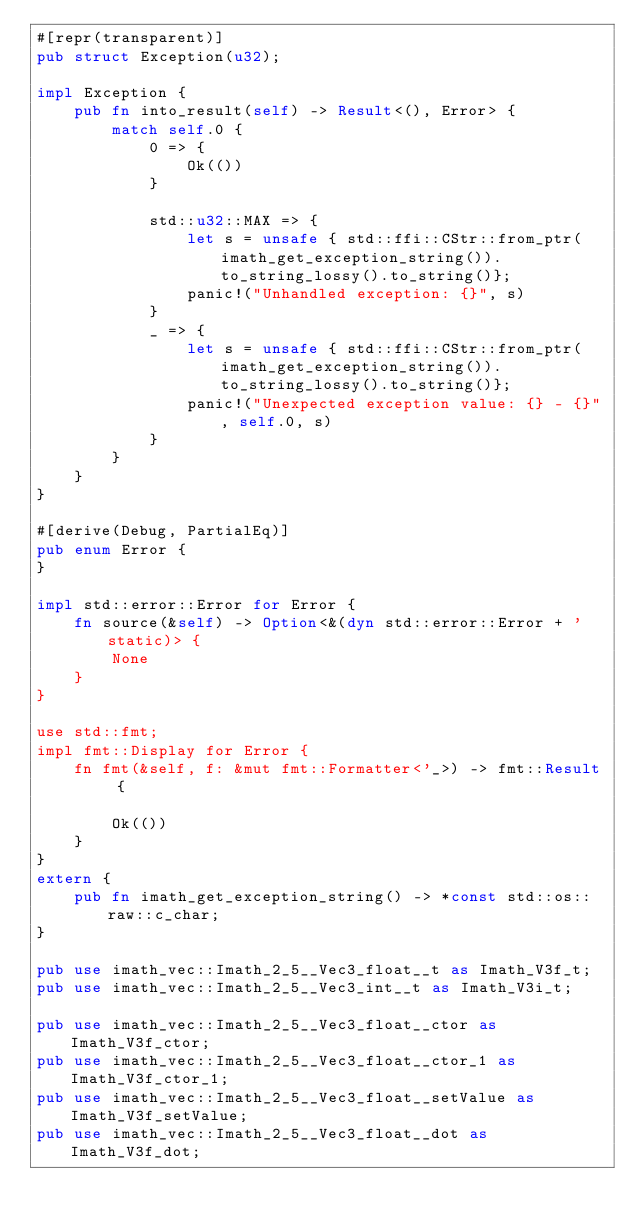Convert code to text. <code><loc_0><loc_0><loc_500><loc_500><_Rust_>#[repr(transparent)] 
pub struct Exception(u32);

impl Exception {
    pub fn into_result(self) -> Result<(), Error> {
        match self.0 {
            0 => {
                Ok(())
            }

            std::u32::MAX => {
                let s = unsafe { std::ffi::CStr::from_ptr(imath_get_exception_string()).to_string_lossy().to_string()};
                panic!("Unhandled exception: {}", s)
            }
            _ => {
                let s = unsafe { std::ffi::CStr::from_ptr(imath_get_exception_string()).to_string_lossy().to_string()};
                panic!("Unexpected exception value: {} - {}", self.0, s)
            }
        }
    }
}

#[derive(Debug, PartialEq)]
pub enum Error {
}

impl std::error::Error for Error {
    fn source(&self) -> Option<&(dyn std::error::Error + 'static)> {
        None
    }
}

use std::fmt;
impl fmt::Display for Error {
    fn fmt(&self, f: &mut fmt::Formatter<'_>) -> fmt::Result {

        Ok(())
    }
}
extern {
    pub fn imath_get_exception_string() -> *const std::os::raw::c_char;
}

pub use imath_vec::Imath_2_5__Vec3_float__t as Imath_V3f_t;
pub use imath_vec::Imath_2_5__Vec3_int__t as Imath_V3i_t;

pub use imath_vec::Imath_2_5__Vec3_float__ctor as Imath_V3f_ctor;
pub use imath_vec::Imath_2_5__Vec3_float__ctor_1 as Imath_V3f_ctor_1;
pub use imath_vec::Imath_2_5__Vec3_float__setValue as Imath_V3f_setValue;
pub use imath_vec::Imath_2_5__Vec3_float__dot as Imath_V3f_dot;</code> 